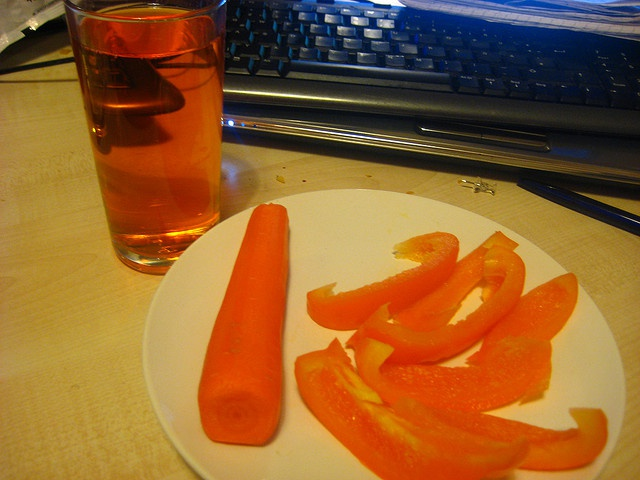Describe the objects in this image and their specific colors. I can see dining table in black, red, olive, and tan tones, keyboard in gray, black, navy, and darkgreen tones, cup in gray, maroon, black, and brown tones, laptop in gray, black, olive, and maroon tones, and carrot in gray, red, and brown tones in this image. 